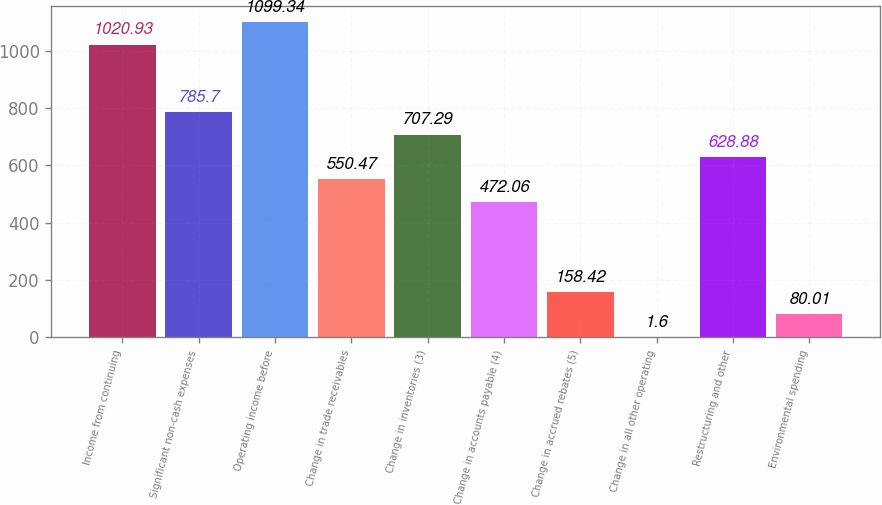Convert chart to OTSL. <chart><loc_0><loc_0><loc_500><loc_500><bar_chart><fcel>Income from continuing<fcel>Significant non-cash expenses<fcel>Operating income before<fcel>Change in trade receivables<fcel>Change in inventories (3)<fcel>Change in accounts payable (4)<fcel>Change in accrued rebates (5)<fcel>Change in all other operating<fcel>Restructuring and other<fcel>Environmental spending<nl><fcel>1020.93<fcel>785.7<fcel>1099.34<fcel>550.47<fcel>707.29<fcel>472.06<fcel>158.42<fcel>1.6<fcel>628.88<fcel>80.01<nl></chart> 